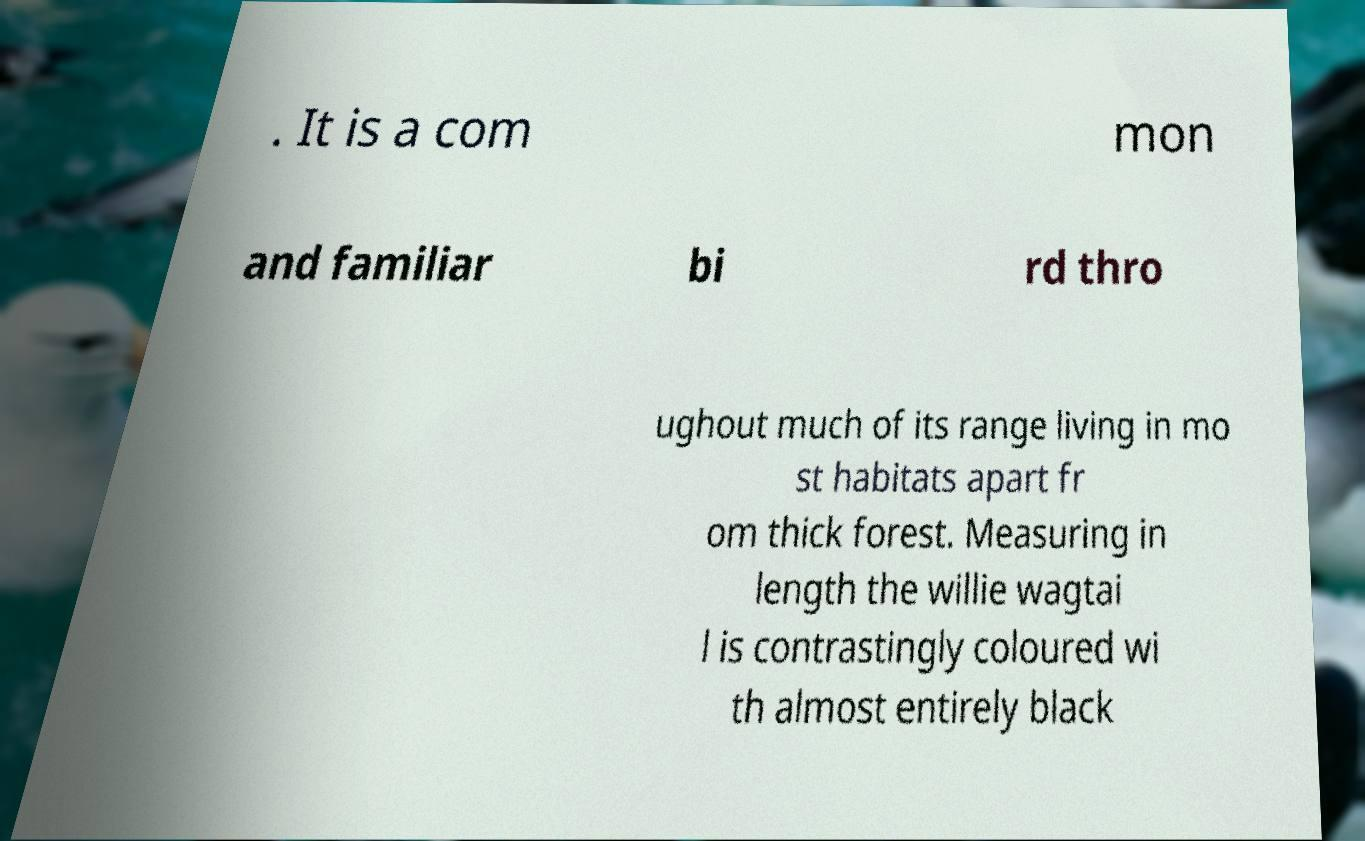I need the written content from this picture converted into text. Can you do that? . It is a com mon and familiar bi rd thro ughout much of its range living in mo st habitats apart fr om thick forest. Measuring in length the willie wagtai l is contrastingly coloured wi th almost entirely black 